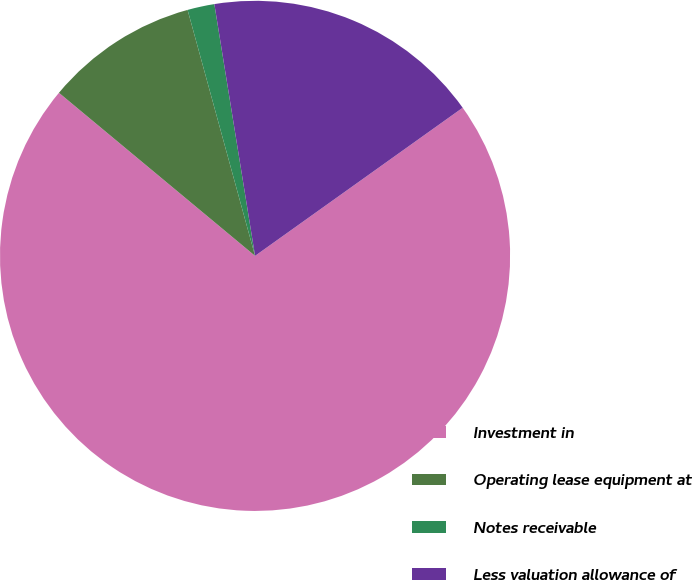Convert chart to OTSL. <chart><loc_0><loc_0><loc_500><loc_500><pie_chart><fcel>Investment in<fcel>Operating lease equipment at<fcel>Notes receivable<fcel>Less valuation allowance of<nl><fcel>70.91%<fcel>9.7%<fcel>1.71%<fcel>17.69%<nl></chart> 